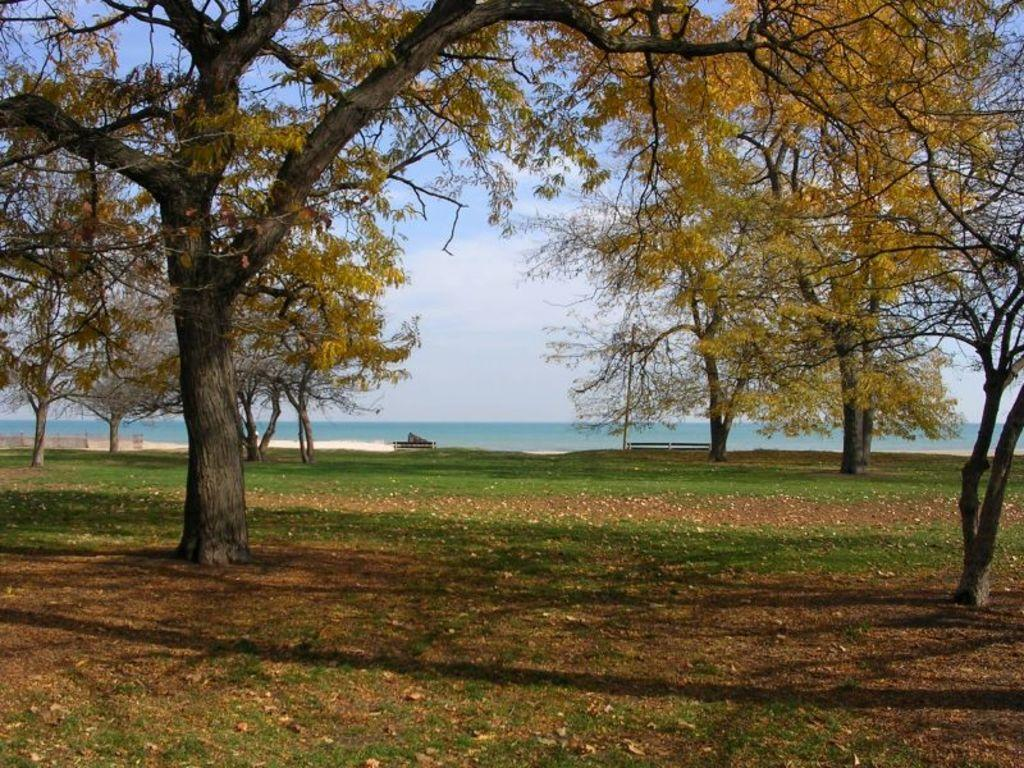What type of vegetation is present on the ground in the image? There are many trees on the ground in the image. What can be seen in the distance behind the trees? There is a beach visible in the background of the image. What type of seating is available near the beach in the image? There are benches in front of the beach in the image. What type of war is being fought on the beach in the image? There is no war or any indication of conflict in the image; it features trees, a beach, and benches. How many times do you need to rub the trees to make them disappear in the image? There is no need to rub the trees in the image, as they are a natural part of the landscape. 